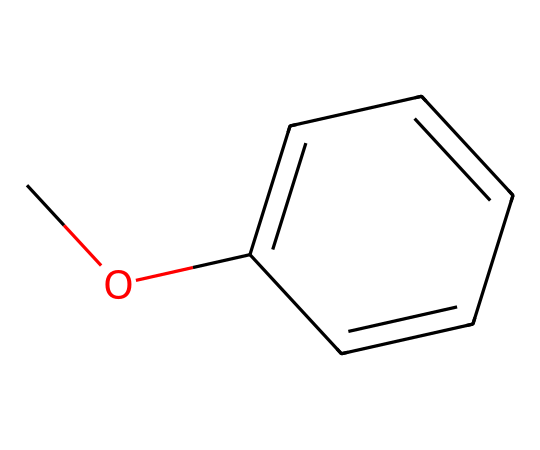What is the name of this chemical? The SMILES representation COc1ccccc1 indicates a compound with a methoxy group (-OCH3) attached to a benzene ring (c1ccccc1), making it anisole.
Answer: anisole How many carbon atoms are in anisole? Anisole has a total of 8 carbon atoms: 1 from the methoxy group and 6 from the benzene ring. Therefore, we count them as shown by the structural components in the SMILES representation.
Answer: 8 What type of functional group is present in anisole? The methoxy group (-OCH3) is a type of ether functional group, which is indicated by the structure having an oxygen atom bonded to two carbon-containing groups (one in the methoxy and the other in the benzene).
Answer: ether How many hydrogen atoms are connected to the benzene ring in anisole? A benzene ring typically has 6 hydrogen atoms, but one is replaced by the methoxy group in anisole, leaving 5 hydrogen atoms bonded to the ring.
Answer: 5 What is the primary reason for anisole's use in scented marketing materials? Anisole has a pleasant aromatic smell due to the benzene ring structure coupled with the methoxy group, making it suitable for scented products.
Answer: aromatic smell Is anisole a polar or nonpolar compound? The presence of the methoxy (-OCH3) group gives anisole a slight polarity, but its overall structure remains predominantly nonpolar due to the benzene ring.
Answer: nonpolar What type of bond connects the oxygen atom to the carbon atom in the methoxy group? The oxygen atom in the methoxy group is connected to the carbon atom by a single bond, as indicated by the '-O' in the SMILES representation.
Answer: single bond 